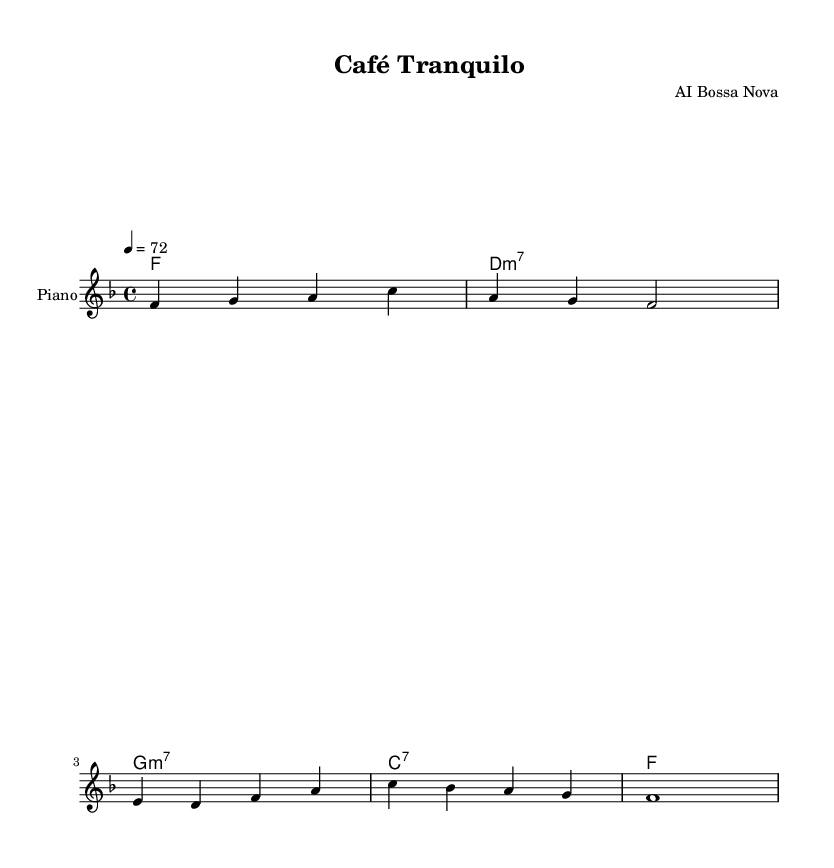What is the key signature of this music? The key signature is F major, which has one flat (B flat). This is indicated by the F note being the tonic and the presence of a flat in the staff.
Answer: F major What is the time signature of this piece? The time signature is 4/4, which is represented at the beginning of the score with the numbers indicating four beats in each measure and a quarter note getting one beat.
Answer: 4/4 What is the tempo marking for this piece? The tempo is marked at 72 beats per minute, shown as "4 = 72" in the score which indicates the metronome marking.
Answer: 72 How many measures are there in the melody? The melody consists of six measures, as each group of notes is separated by vertical lines called measure bars, which define the boundaries of each measure.
Answer: 6 What is the first chord in the harmonies? The first chord is F major, indicated at the start of the harmonies section where the chord is labeled as "f1", meaning it lasts for the entire measure.
Answer: F What type of instrumentation is indicated for this piece? The instrumentation is for piano, which is specified in the staff with the instrument name "Piano" at the beginning, indicating that the sheet music is meant to be played for this instrument.
Answer: Piano What type of music genre does this piece belong to? This piece belongs to the Bossa Nova genre, which is characterized by its smooth rhythms and harmonic complexity, characteristics evident in the chord choices and the laid-back style of the melody.
Answer: Bossa Nova 